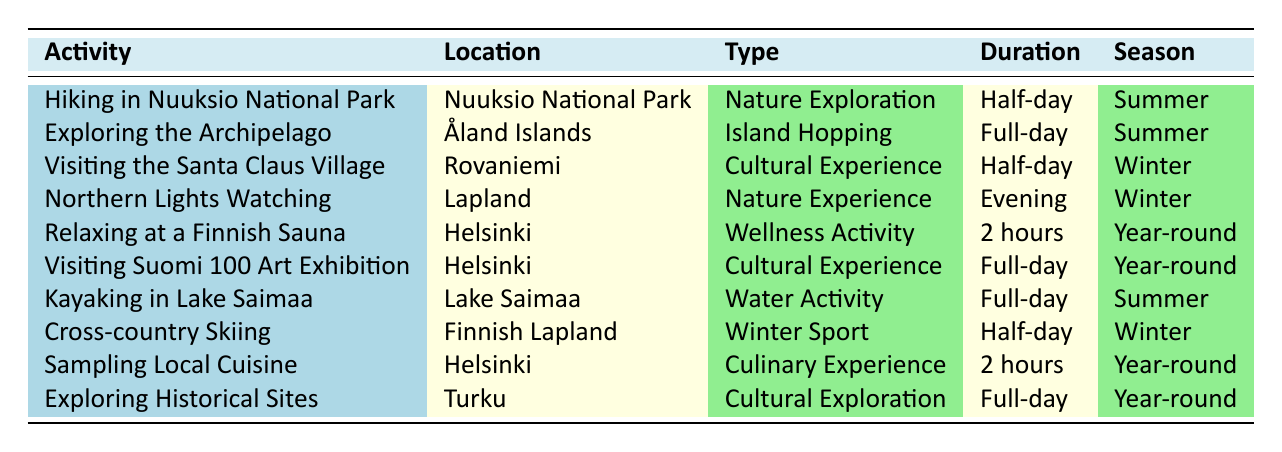What activity has the longest duration listed? The activities listed show varying durations, with "Exploring the Archipelago," "Kayaking in Lake Saimaa," and "Visiting Suomi 100 Art Exhibition" all marked as Full-day activities, which is the longest duration presented in the table.
Answer: Full-day How many activities can be enjoyed during Winter? The table lists three activities for Winter: "Visiting the Santa Claus Village," "Northern Lights Watching," and "Cross-country Skiing." Counting these entries gives us a total of three activities.
Answer: 3 Is "Relaxing at a Finnish Sauna" categorized as a Nature Exploration activity? The table categorizes "Relaxing at a Finnish Sauna" under "Wellness Activity," which does not classify it as a Nature Exploration activity. Thus, the answer is no.
Answer: No What is the total number of Full-day activities available for retirees? In the table, the Full-day activities are "Exploring the Archipelago," "Visiting Suomi 100 Art Exhibition," "Kayaking in Lake Saimaa," and "Exploring Historical Sites." Summing them gives a total of four Full-day activities.
Answer: 4 During which season can retirees enjoy "Cross-country Skiing"? The activity "Cross-country Skiing" is specifically listed under the Winter season according to the table's entries.
Answer: Winter Are there more activities in Summer or Winter? The table shows four activities under Summer: "Hiking in Nuuksio National Park," "Exploring the Archipelago," "Kayaking in Lake Saimaa," and one activity under Winter "Cross-country Skiing." Therefore, there are more activities in Summer than Winter.
Answer: Yes What type of experience is "Northern Lights Watching"? The table categorizes "Northern Lights Watching" as a "Nature Experience." This is the type assigned to this activity.
Answer: Nature Experience Which city has the most activities listed? By reviewing the table, Helsinki has three activities listed: "Relaxing at a Finnish Sauna," "Visiting Suomi 100 Art Exhibition," and "Sampling Local Cuisine." Other locations have fewer activities, confirming Helsinki as the city with the most activities.
Answer: Helsinki 